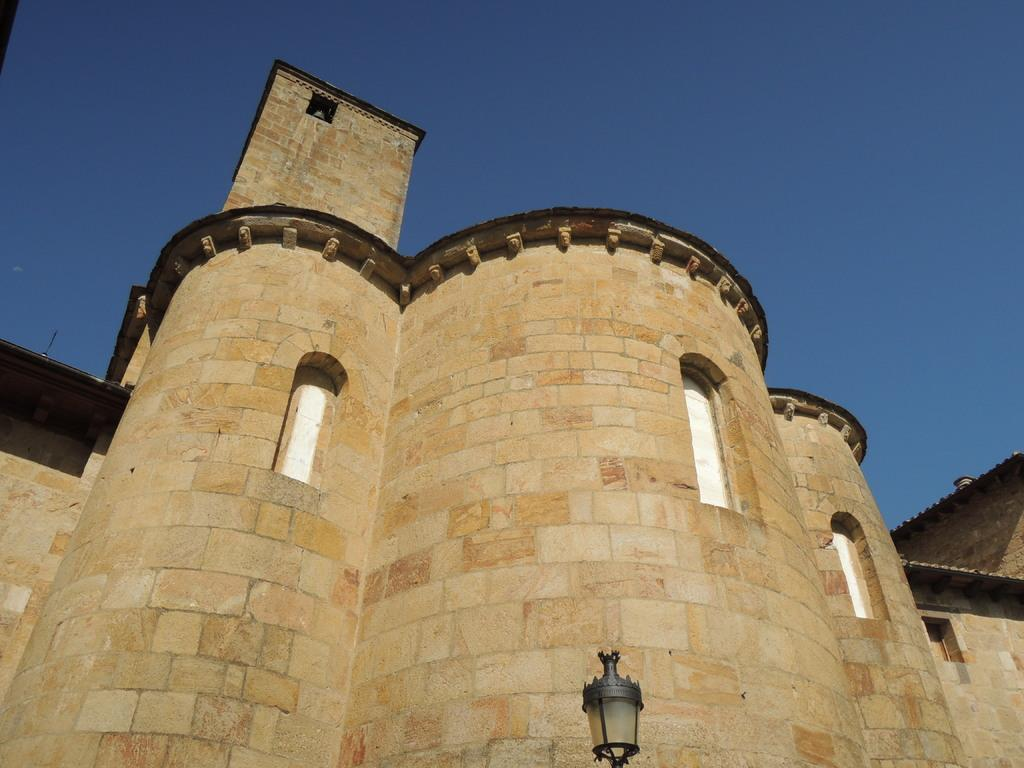What is the main structure in the center of the image? There is a castle in the center of the image. What can be seen at the bottom of the image? There is a light at the bottom of the image. What is visible in the background of the image? The sky is visible in the background of the image. Where is the locket located in the image? There is no locket present in the image. What type of machine can be seen operating in the castle? There is no machine visible in the image; it only features a castle, a light, and the sky. 